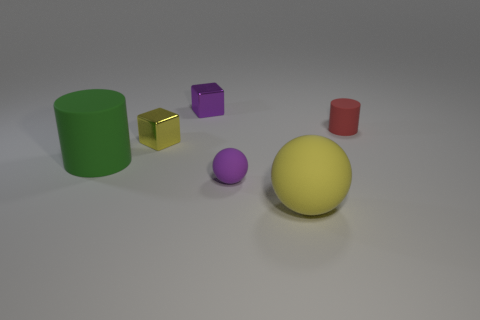Add 2 gray cubes. How many objects exist? 8 Subtract all spheres. How many objects are left? 4 Subtract all large blue matte things. Subtract all tiny yellow metal objects. How many objects are left? 5 Add 3 metal objects. How many metal objects are left? 5 Add 3 tiny spheres. How many tiny spheres exist? 4 Subtract 0 blue balls. How many objects are left? 6 